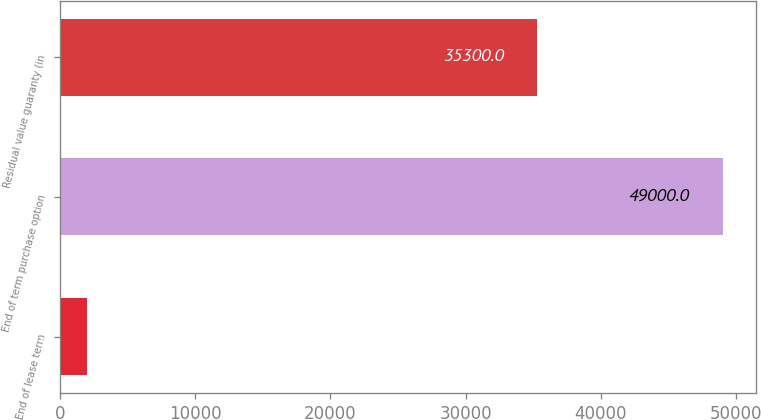<chart> <loc_0><loc_0><loc_500><loc_500><bar_chart><fcel>End of lease term<fcel>End of term purchase option<fcel>Residual value guaranty (in<nl><fcel>2011<fcel>49000<fcel>35300<nl></chart> 